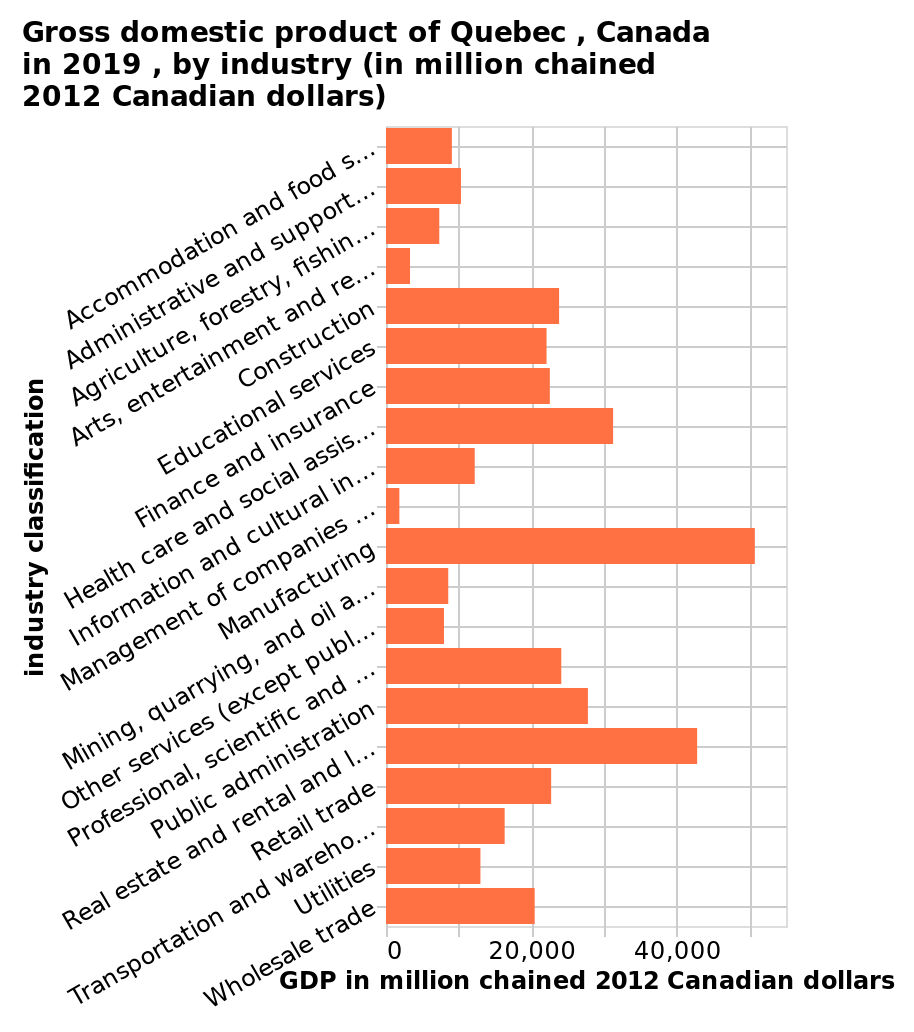<image>
What is the name of the bar plot? The bar plot is named "Gross domestic product of Quebec, Canada in 2019, by industry (in million chained 2012 Canadian dollars)." What does the bar plot show for each industry? The bar plot shows the Gross Domestic Product (GDP) of each industry in Quebec, Canada in 2019, measured in million chained 2012 Canadian dollars. please describe the details of the chart This bar plot is named Gross domestic product of Quebec , Canada in 2019 , by industry (in million chained 2012 Canadian dollars). The y-axis shows industry classification while the x-axis measures GDP in million chained 2012 Canadian dollars. 